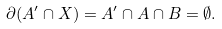Convert formula to latex. <formula><loc_0><loc_0><loc_500><loc_500>\partial ( A ^ { \prime } \cap X ) = A ^ { \prime } \cap A \cap B = \emptyset .</formula> 